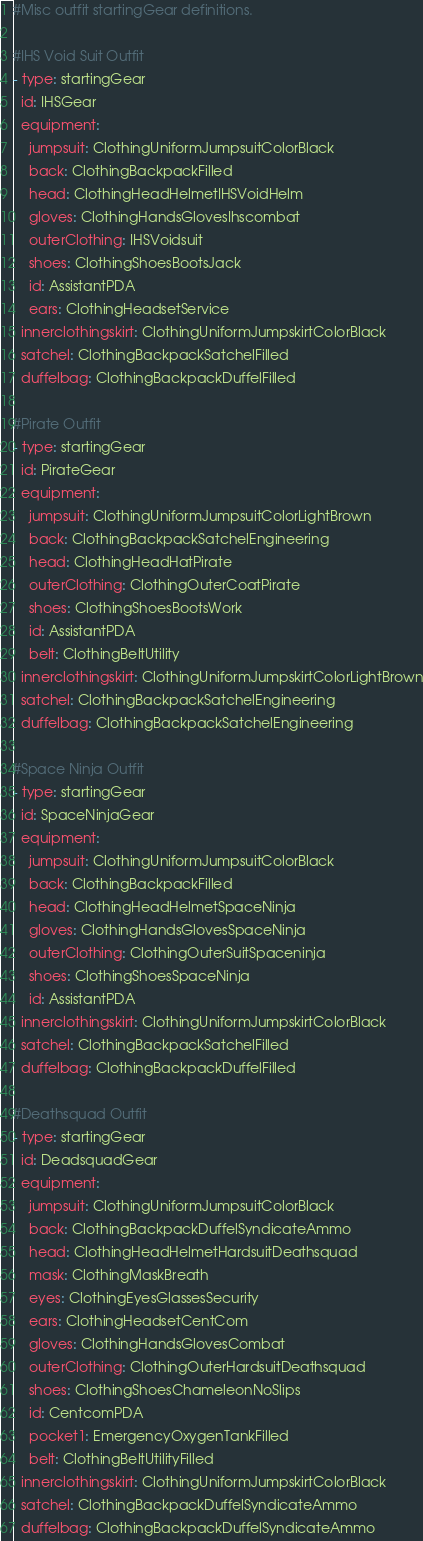<code> <loc_0><loc_0><loc_500><loc_500><_YAML_>#Misc outfit startingGear definitions.

#IHS Void Suit Outfit
- type: startingGear
  id: IHSGear
  equipment:
    jumpsuit: ClothingUniformJumpsuitColorBlack
    back: ClothingBackpackFilled
    head: ClothingHeadHelmetIHSVoidHelm
    gloves: ClothingHandsGlovesIhscombat
    outerClothing: IHSVoidsuit
    shoes: ClothingShoesBootsJack
    id: AssistantPDA
    ears: ClothingHeadsetService
  innerclothingskirt: ClothingUniformJumpskirtColorBlack
  satchel: ClothingBackpackSatchelFilled
  duffelbag: ClothingBackpackDuffelFilled

#Pirate Outfit
- type: startingGear
  id: PirateGear
  equipment:
    jumpsuit: ClothingUniformJumpsuitColorLightBrown
    back: ClothingBackpackSatchelEngineering
    head: ClothingHeadHatPirate
    outerClothing: ClothingOuterCoatPirate
    shoes: ClothingShoesBootsWork
    id: AssistantPDA
    belt: ClothingBeltUtility
  innerclothingskirt: ClothingUniformJumpskirtColorLightBrown
  satchel: ClothingBackpackSatchelEngineering
  duffelbag: ClothingBackpackSatchelEngineering

#Space Ninja Outfit
- type: startingGear
  id: SpaceNinjaGear
  equipment:
    jumpsuit: ClothingUniformJumpsuitColorBlack
    back: ClothingBackpackFilled
    head: ClothingHeadHelmetSpaceNinja
    gloves: ClothingHandsGlovesSpaceNinja
    outerClothing: ClothingOuterSuitSpaceninja
    shoes: ClothingShoesSpaceNinja
    id: AssistantPDA
  innerclothingskirt: ClothingUniformJumpskirtColorBlack
  satchel: ClothingBackpackSatchelFilled
  duffelbag: ClothingBackpackDuffelFilled

#Deathsquad Outfit
- type: startingGear
  id: DeadsquadGear
  equipment:
    jumpsuit: ClothingUniformJumpsuitColorBlack
    back: ClothingBackpackDuffelSyndicateAmmo
    head: ClothingHeadHelmetHardsuitDeathsquad
    mask: ClothingMaskBreath
    eyes: ClothingEyesGlassesSecurity
    ears: ClothingHeadsetCentCom
    gloves: ClothingHandsGlovesCombat
    outerClothing: ClothingOuterHardsuitDeathsquad
    shoes: ClothingShoesChameleonNoSlips
    id: CentcomPDA
    pocket1: EmergencyOxygenTankFilled
    belt: ClothingBeltUtilityFilled
  innerclothingskirt: ClothingUniformJumpskirtColorBlack
  satchel: ClothingBackpackDuffelSyndicateAmmo
  duffelbag: ClothingBackpackDuffelSyndicateAmmo
</code> 